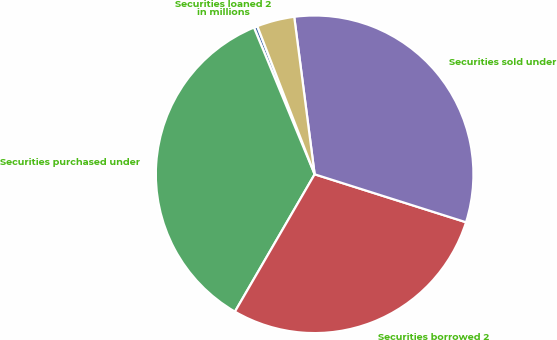Convert chart. <chart><loc_0><loc_0><loc_500><loc_500><pie_chart><fcel>in millions<fcel>Securities purchased under<fcel>Securities borrowed 2<fcel>Securities sold under<fcel>Securities loaned 2<nl><fcel>0.37%<fcel>35.38%<fcel>28.48%<fcel>31.93%<fcel>3.82%<nl></chart> 